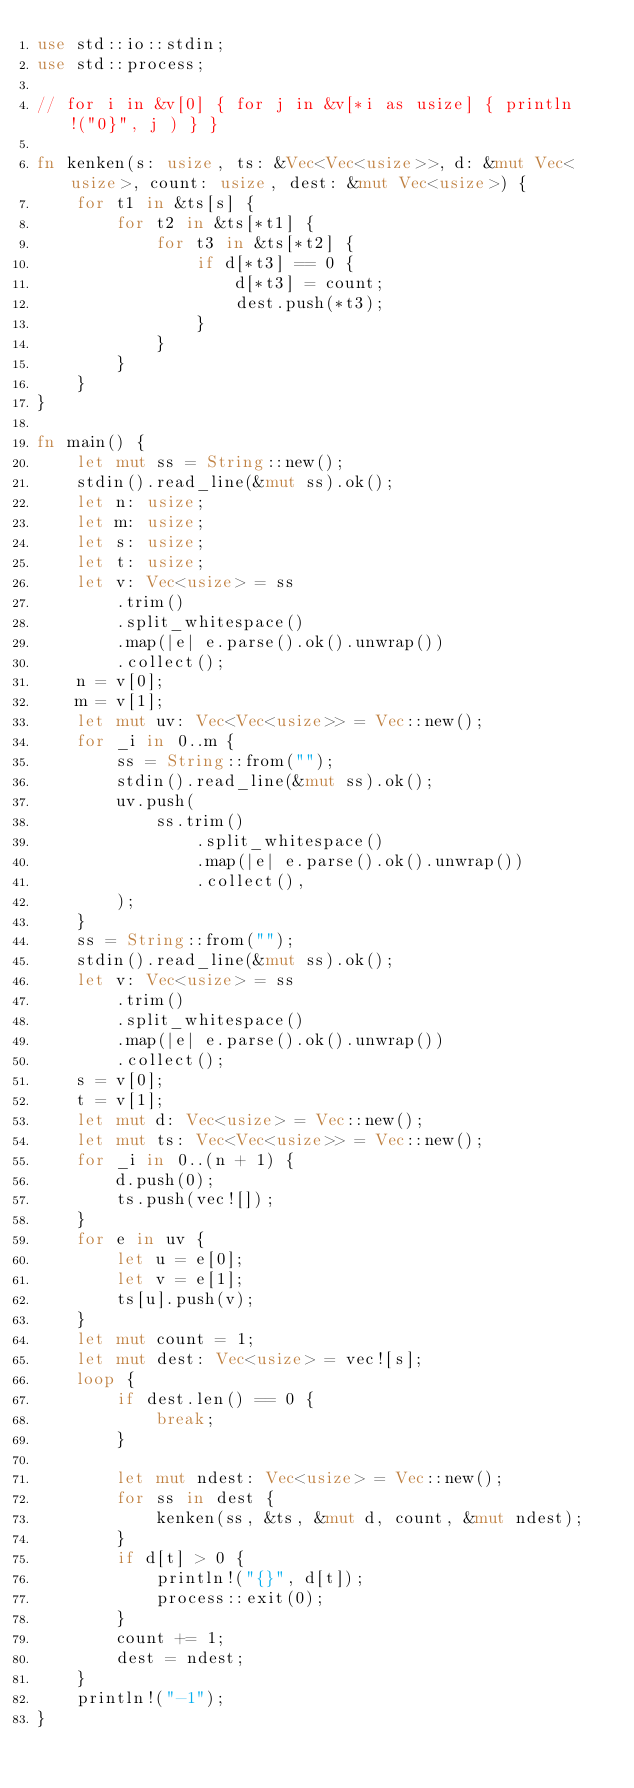Convert code to text. <code><loc_0><loc_0><loc_500><loc_500><_Rust_>use std::io::stdin;
use std::process;

// for i in &v[0] { for j in &v[*i as usize] { println!("0}", j ) } }

fn kenken(s: usize, ts: &Vec<Vec<usize>>, d: &mut Vec<usize>, count: usize, dest: &mut Vec<usize>) {
    for t1 in &ts[s] {
        for t2 in &ts[*t1] {
            for t3 in &ts[*t2] {
                if d[*t3] == 0 {
                    d[*t3] = count;
                    dest.push(*t3);
                }
            }
        }
    }
}

fn main() {
    let mut ss = String::new();
    stdin().read_line(&mut ss).ok();
    let n: usize;
    let m: usize;
    let s: usize;
    let t: usize;
    let v: Vec<usize> = ss
        .trim()
        .split_whitespace()
        .map(|e| e.parse().ok().unwrap())
        .collect();
    n = v[0];
    m = v[1];
    let mut uv: Vec<Vec<usize>> = Vec::new();
    for _i in 0..m {
        ss = String::from("");
        stdin().read_line(&mut ss).ok();
        uv.push(
            ss.trim()
                .split_whitespace()
                .map(|e| e.parse().ok().unwrap())
                .collect(),
        );
    }
    ss = String::from("");
    stdin().read_line(&mut ss).ok();
    let v: Vec<usize> = ss
        .trim()
        .split_whitespace()
        .map(|e| e.parse().ok().unwrap())
        .collect();
    s = v[0];
    t = v[1];
    let mut d: Vec<usize> = Vec::new();
    let mut ts: Vec<Vec<usize>> = Vec::new();
    for _i in 0..(n + 1) {
        d.push(0);
        ts.push(vec![]);
    }
    for e in uv {
        let u = e[0];
        let v = e[1];
        ts[u].push(v);
    }
    let mut count = 1;
    let mut dest: Vec<usize> = vec![s];
    loop {
        if dest.len() == 0 {
            break;
        }

        let mut ndest: Vec<usize> = Vec::new();
        for ss in dest {
            kenken(ss, &ts, &mut d, count, &mut ndest);
        }
        if d[t] > 0 {
            println!("{}", d[t]);
            process::exit(0);
        }
        count += 1;
        dest = ndest;
    }
    println!("-1");
}
</code> 